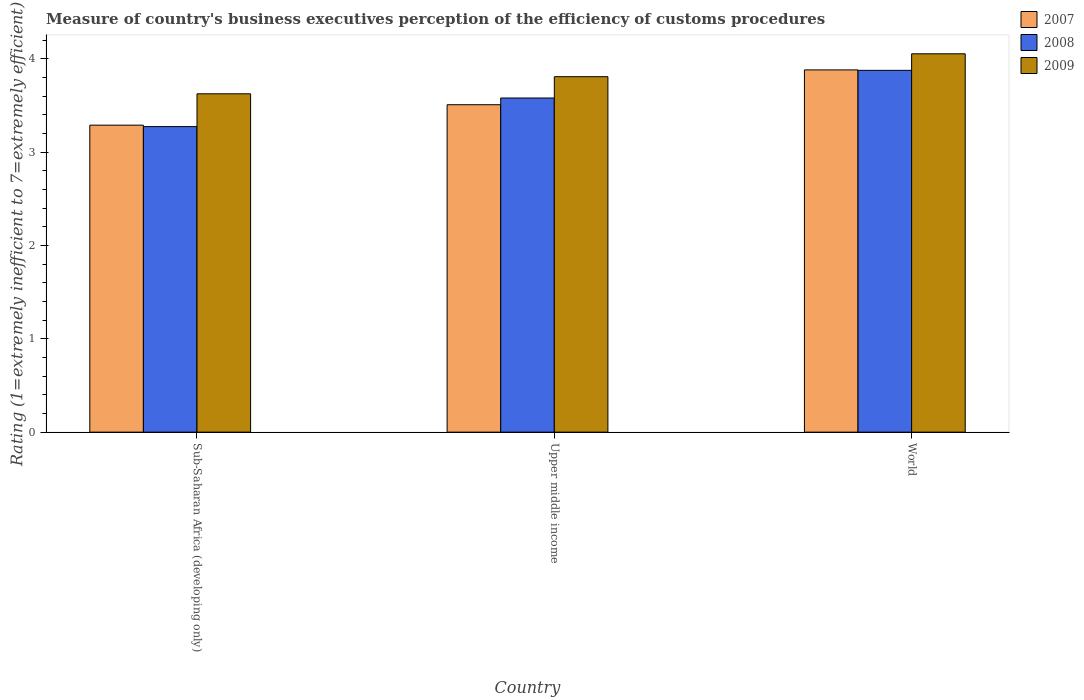How many groups of bars are there?
Keep it short and to the point. 3. How many bars are there on the 3rd tick from the left?
Offer a terse response. 3. What is the label of the 1st group of bars from the left?
Your response must be concise. Sub-Saharan Africa (developing only). In how many cases, is the number of bars for a given country not equal to the number of legend labels?
Your answer should be very brief. 0. What is the rating of the efficiency of customs procedure in 2008 in World?
Your response must be concise. 3.88. Across all countries, what is the maximum rating of the efficiency of customs procedure in 2008?
Ensure brevity in your answer.  3.88. Across all countries, what is the minimum rating of the efficiency of customs procedure in 2008?
Offer a very short reply. 3.27. In which country was the rating of the efficiency of customs procedure in 2007 minimum?
Keep it short and to the point. Sub-Saharan Africa (developing only). What is the total rating of the efficiency of customs procedure in 2008 in the graph?
Give a very brief answer. 10.73. What is the difference between the rating of the efficiency of customs procedure in 2007 in Sub-Saharan Africa (developing only) and that in World?
Offer a very short reply. -0.59. What is the difference between the rating of the efficiency of customs procedure in 2009 in Sub-Saharan Africa (developing only) and the rating of the efficiency of customs procedure in 2008 in World?
Provide a short and direct response. -0.25. What is the average rating of the efficiency of customs procedure in 2009 per country?
Your response must be concise. 3.83. What is the difference between the rating of the efficiency of customs procedure of/in 2007 and rating of the efficiency of customs procedure of/in 2008 in Sub-Saharan Africa (developing only)?
Make the answer very short. 0.02. What is the ratio of the rating of the efficiency of customs procedure in 2009 in Upper middle income to that in World?
Provide a succinct answer. 0.94. Is the rating of the efficiency of customs procedure in 2007 in Sub-Saharan Africa (developing only) less than that in World?
Make the answer very short. Yes. Is the difference between the rating of the efficiency of customs procedure in 2007 in Sub-Saharan Africa (developing only) and World greater than the difference between the rating of the efficiency of customs procedure in 2008 in Sub-Saharan Africa (developing only) and World?
Provide a succinct answer. Yes. What is the difference between the highest and the second highest rating of the efficiency of customs procedure in 2008?
Offer a terse response. -0.3. What is the difference between the highest and the lowest rating of the efficiency of customs procedure in 2009?
Offer a terse response. 0.43. In how many countries, is the rating of the efficiency of customs procedure in 2007 greater than the average rating of the efficiency of customs procedure in 2007 taken over all countries?
Your answer should be compact. 1. Is the sum of the rating of the efficiency of customs procedure in 2008 in Upper middle income and World greater than the maximum rating of the efficiency of customs procedure in 2009 across all countries?
Your answer should be very brief. Yes. What does the 3rd bar from the left in Sub-Saharan Africa (developing only) represents?
Provide a short and direct response. 2009. What does the 1st bar from the right in World represents?
Give a very brief answer. 2009. How many bars are there?
Keep it short and to the point. 9. What is the difference between two consecutive major ticks on the Y-axis?
Offer a very short reply. 1. Does the graph contain any zero values?
Ensure brevity in your answer.  No. Does the graph contain grids?
Provide a succinct answer. No. Where does the legend appear in the graph?
Your answer should be compact. Top right. How many legend labels are there?
Keep it short and to the point. 3. How are the legend labels stacked?
Make the answer very short. Vertical. What is the title of the graph?
Offer a very short reply. Measure of country's business executives perception of the efficiency of customs procedures. Does "1990" appear as one of the legend labels in the graph?
Offer a very short reply. No. What is the label or title of the X-axis?
Your answer should be compact. Country. What is the label or title of the Y-axis?
Your answer should be very brief. Rating (1=extremely inefficient to 7=extremely efficient). What is the Rating (1=extremely inefficient to 7=extremely efficient) of 2007 in Sub-Saharan Africa (developing only)?
Your response must be concise. 3.29. What is the Rating (1=extremely inefficient to 7=extremely efficient) in 2008 in Sub-Saharan Africa (developing only)?
Give a very brief answer. 3.27. What is the Rating (1=extremely inefficient to 7=extremely efficient) in 2009 in Sub-Saharan Africa (developing only)?
Provide a short and direct response. 3.63. What is the Rating (1=extremely inefficient to 7=extremely efficient) of 2007 in Upper middle income?
Offer a very short reply. 3.51. What is the Rating (1=extremely inefficient to 7=extremely efficient) in 2008 in Upper middle income?
Ensure brevity in your answer.  3.58. What is the Rating (1=extremely inefficient to 7=extremely efficient) of 2009 in Upper middle income?
Your answer should be very brief. 3.81. What is the Rating (1=extremely inefficient to 7=extremely efficient) of 2007 in World?
Ensure brevity in your answer.  3.88. What is the Rating (1=extremely inefficient to 7=extremely efficient) in 2008 in World?
Ensure brevity in your answer.  3.88. What is the Rating (1=extremely inefficient to 7=extremely efficient) in 2009 in World?
Provide a succinct answer. 4.06. Across all countries, what is the maximum Rating (1=extremely inefficient to 7=extremely efficient) of 2007?
Make the answer very short. 3.88. Across all countries, what is the maximum Rating (1=extremely inefficient to 7=extremely efficient) in 2008?
Offer a very short reply. 3.88. Across all countries, what is the maximum Rating (1=extremely inefficient to 7=extremely efficient) in 2009?
Keep it short and to the point. 4.06. Across all countries, what is the minimum Rating (1=extremely inefficient to 7=extremely efficient) of 2007?
Give a very brief answer. 3.29. Across all countries, what is the minimum Rating (1=extremely inefficient to 7=extremely efficient) of 2008?
Make the answer very short. 3.27. Across all countries, what is the minimum Rating (1=extremely inefficient to 7=extremely efficient) of 2009?
Provide a short and direct response. 3.63. What is the total Rating (1=extremely inefficient to 7=extremely efficient) of 2007 in the graph?
Ensure brevity in your answer.  10.68. What is the total Rating (1=extremely inefficient to 7=extremely efficient) in 2008 in the graph?
Keep it short and to the point. 10.73. What is the total Rating (1=extremely inefficient to 7=extremely efficient) in 2009 in the graph?
Your response must be concise. 11.49. What is the difference between the Rating (1=extremely inefficient to 7=extremely efficient) in 2007 in Sub-Saharan Africa (developing only) and that in Upper middle income?
Offer a terse response. -0.22. What is the difference between the Rating (1=extremely inefficient to 7=extremely efficient) of 2008 in Sub-Saharan Africa (developing only) and that in Upper middle income?
Ensure brevity in your answer.  -0.31. What is the difference between the Rating (1=extremely inefficient to 7=extremely efficient) of 2009 in Sub-Saharan Africa (developing only) and that in Upper middle income?
Offer a terse response. -0.18. What is the difference between the Rating (1=extremely inefficient to 7=extremely efficient) in 2007 in Sub-Saharan Africa (developing only) and that in World?
Your response must be concise. -0.59. What is the difference between the Rating (1=extremely inefficient to 7=extremely efficient) of 2008 in Sub-Saharan Africa (developing only) and that in World?
Offer a very short reply. -0.6. What is the difference between the Rating (1=extremely inefficient to 7=extremely efficient) of 2009 in Sub-Saharan Africa (developing only) and that in World?
Ensure brevity in your answer.  -0.43. What is the difference between the Rating (1=extremely inefficient to 7=extremely efficient) of 2007 in Upper middle income and that in World?
Provide a succinct answer. -0.37. What is the difference between the Rating (1=extremely inefficient to 7=extremely efficient) in 2008 in Upper middle income and that in World?
Your answer should be very brief. -0.3. What is the difference between the Rating (1=extremely inefficient to 7=extremely efficient) in 2009 in Upper middle income and that in World?
Offer a very short reply. -0.25. What is the difference between the Rating (1=extremely inefficient to 7=extremely efficient) in 2007 in Sub-Saharan Africa (developing only) and the Rating (1=extremely inefficient to 7=extremely efficient) in 2008 in Upper middle income?
Your answer should be very brief. -0.29. What is the difference between the Rating (1=extremely inefficient to 7=extremely efficient) in 2007 in Sub-Saharan Africa (developing only) and the Rating (1=extremely inefficient to 7=extremely efficient) in 2009 in Upper middle income?
Provide a short and direct response. -0.52. What is the difference between the Rating (1=extremely inefficient to 7=extremely efficient) in 2008 in Sub-Saharan Africa (developing only) and the Rating (1=extremely inefficient to 7=extremely efficient) in 2009 in Upper middle income?
Your response must be concise. -0.54. What is the difference between the Rating (1=extremely inefficient to 7=extremely efficient) in 2007 in Sub-Saharan Africa (developing only) and the Rating (1=extremely inefficient to 7=extremely efficient) in 2008 in World?
Keep it short and to the point. -0.59. What is the difference between the Rating (1=extremely inefficient to 7=extremely efficient) in 2007 in Sub-Saharan Africa (developing only) and the Rating (1=extremely inefficient to 7=extremely efficient) in 2009 in World?
Ensure brevity in your answer.  -0.76. What is the difference between the Rating (1=extremely inefficient to 7=extremely efficient) in 2008 in Sub-Saharan Africa (developing only) and the Rating (1=extremely inefficient to 7=extremely efficient) in 2009 in World?
Provide a short and direct response. -0.78. What is the difference between the Rating (1=extremely inefficient to 7=extremely efficient) in 2007 in Upper middle income and the Rating (1=extremely inefficient to 7=extremely efficient) in 2008 in World?
Your answer should be compact. -0.37. What is the difference between the Rating (1=extremely inefficient to 7=extremely efficient) in 2007 in Upper middle income and the Rating (1=extremely inefficient to 7=extremely efficient) in 2009 in World?
Ensure brevity in your answer.  -0.55. What is the difference between the Rating (1=extremely inefficient to 7=extremely efficient) in 2008 in Upper middle income and the Rating (1=extremely inefficient to 7=extremely efficient) in 2009 in World?
Make the answer very short. -0.47. What is the average Rating (1=extremely inefficient to 7=extremely efficient) in 2007 per country?
Offer a very short reply. 3.56. What is the average Rating (1=extremely inefficient to 7=extremely efficient) in 2008 per country?
Your answer should be very brief. 3.58. What is the average Rating (1=extremely inefficient to 7=extremely efficient) in 2009 per country?
Ensure brevity in your answer.  3.83. What is the difference between the Rating (1=extremely inefficient to 7=extremely efficient) in 2007 and Rating (1=extremely inefficient to 7=extremely efficient) in 2008 in Sub-Saharan Africa (developing only)?
Keep it short and to the point. 0.02. What is the difference between the Rating (1=extremely inefficient to 7=extremely efficient) in 2007 and Rating (1=extremely inefficient to 7=extremely efficient) in 2009 in Sub-Saharan Africa (developing only)?
Make the answer very short. -0.34. What is the difference between the Rating (1=extremely inefficient to 7=extremely efficient) in 2008 and Rating (1=extremely inefficient to 7=extremely efficient) in 2009 in Sub-Saharan Africa (developing only)?
Provide a short and direct response. -0.35. What is the difference between the Rating (1=extremely inefficient to 7=extremely efficient) of 2007 and Rating (1=extremely inefficient to 7=extremely efficient) of 2008 in Upper middle income?
Keep it short and to the point. -0.07. What is the difference between the Rating (1=extremely inefficient to 7=extremely efficient) of 2007 and Rating (1=extremely inefficient to 7=extremely efficient) of 2009 in Upper middle income?
Your answer should be compact. -0.3. What is the difference between the Rating (1=extremely inefficient to 7=extremely efficient) in 2008 and Rating (1=extremely inefficient to 7=extremely efficient) in 2009 in Upper middle income?
Ensure brevity in your answer.  -0.23. What is the difference between the Rating (1=extremely inefficient to 7=extremely efficient) of 2007 and Rating (1=extremely inefficient to 7=extremely efficient) of 2008 in World?
Your answer should be very brief. 0. What is the difference between the Rating (1=extremely inefficient to 7=extremely efficient) of 2007 and Rating (1=extremely inefficient to 7=extremely efficient) of 2009 in World?
Give a very brief answer. -0.17. What is the difference between the Rating (1=extremely inefficient to 7=extremely efficient) of 2008 and Rating (1=extremely inefficient to 7=extremely efficient) of 2009 in World?
Provide a short and direct response. -0.18. What is the ratio of the Rating (1=extremely inefficient to 7=extremely efficient) in 2007 in Sub-Saharan Africa (developing only) to that in Upper middle income?
Your answer should be compact. 0.94. What is the ratio of the Rating (1=extremely inefficient to 7=extremely efficient) in 2008 in Sub-Saharan Africa (developing only) to that in Upper middle income?
Give a very brief answer. 0.91. What is the ratio of the Rating (1=extremely inefficient to 7=extremely efficient) in 2009 in Sub-Saharan Africa (developing only) to that in Upper middle income?
Your response must be concise. 0.95. What is the ratio of the Rating (1=extremely inefficient to 7=extremely efficient) of 2007 in Sub-Saharan Africa (developing only) to that in World?
Ensure brevity in your answer.  0.85. What is the ratio of the Rating (1=extremely inefficient to 7=extremely efficient) in 2008 in Sub-Saharan Africa (developing only) to that in World?
Provide a short and direct response. 0.84. What is the ratio of the Rating (1=extremely inefficient to 7=extremely efficient) of 2009 in Sub-Saharan Africa (developing only) to that in World?
Offer a terse response. 0.89. What is the ratio of the Rating (1=extremely inefficient to 7=extremely efficient) of 2007 in Upper middle income to that in World?
Your answer should be compact. 0.9. What is the ratio of the Rating (1=extremely inefficient to 7=extremely efficient) of 2008 in Upper middle income to that in World?
Your response must be concise. 0.92. What is the ratio of the Rating (1=extremely inefficient to 7=extremely efficient) of 2009 in Upper middle income to that in World?
Keep it short and to the point. 0.94. What is the difference between the highest and the second highest Rating (1=extremely inefficient to 7=extremely efficient) in 2007?
Keep it short and to the point. 0.37. What is the difference between the highest and the second highest Rating (1=extremely inefficient to 7=extremely efficient) in 2008?
Ensure brevity in your answer.  0.3. What is the difference between the highest and the second highest Rating (1=extremely inefficient to 7=extremely efficient) of 2009?
Your response must be concise. 0.25. What is the difference between the highest and the lowest Rating (1=extremely inefficient to 7=extremely efficient) of 2007?
Offer a very short reply. 0.59. What is the difference between the highest and the lowest Rating (1=extremely inefficient to 7=extremely efficient) in 2008?
Keep it short and to the point. 0.6. What is the difference between the highest and the lowest Rating (1=extremely inefficient to 7=extremely efficient) of 2009?
Ensure brevity in your answer.  0.43. 